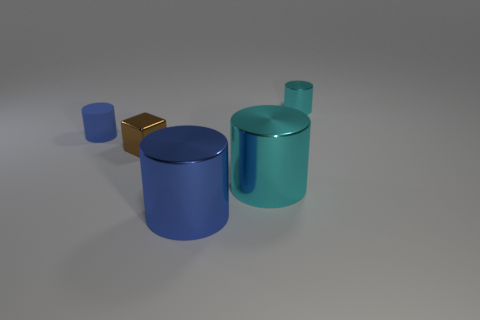Add 2 large yellow cylinders. How many objects exist? 7 Subtract all blocks. How many objects are left? 4 Subtract all small purple matte cubes. Subtract all tiny cubes. How many objects are left? 4 Add 2 large cyan metallic cylinders. How many large cyan metallic cylinders are left? 3 Add 5 shiny cylinders. How many shiny cylinders exist? 8 Subtract 1 brown blocks. How many objects are left? 4 